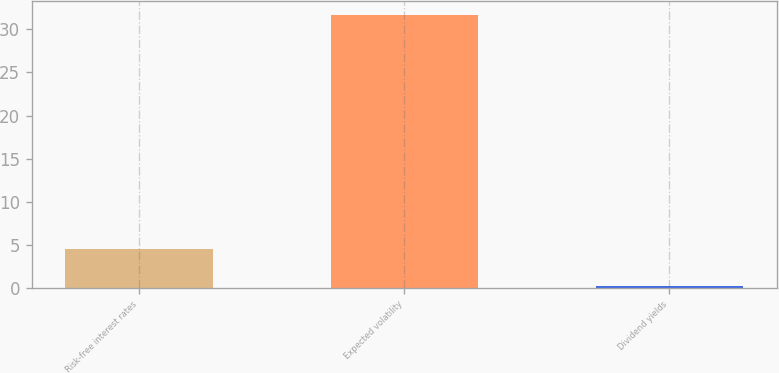Convert chart to OTSL. <chart><loc_0><loc_0><loc_500><loc_500><bar_chart><fcel>Risk-free interest rates<fcel>Expected volatility<fcel>Dividend yields<nl><fcel>4.49<fcel>31.67<fcel>0.19<nl></chart> 